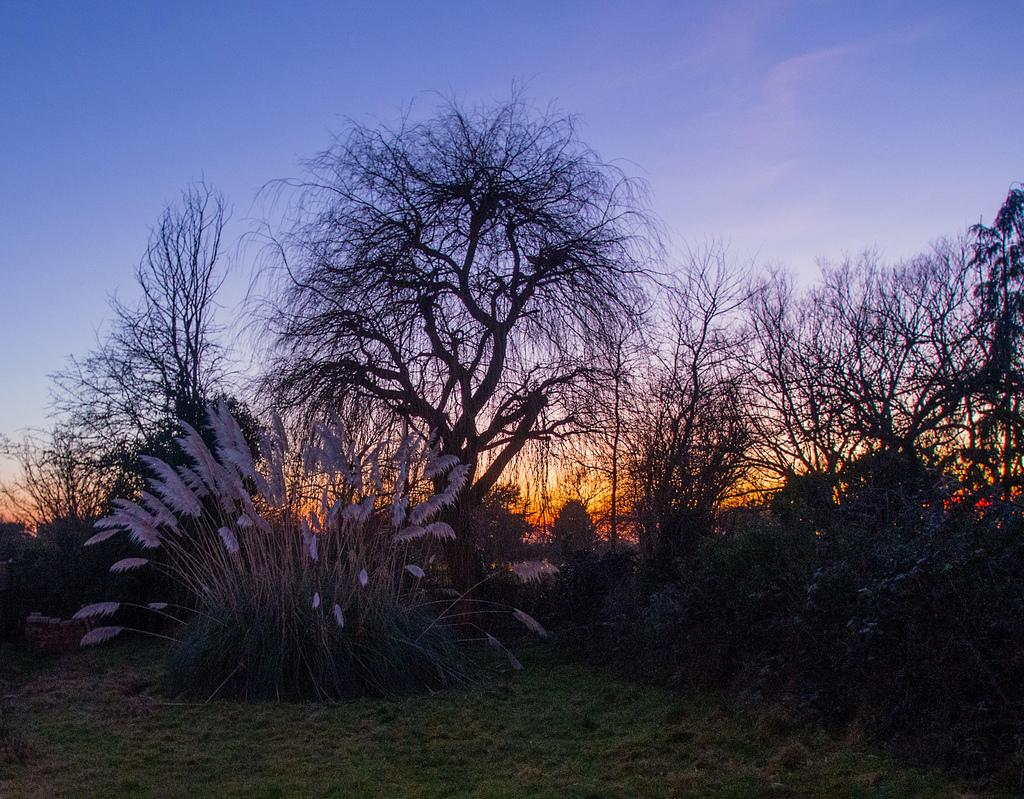What type of vegetation is present on the ground in the image? There are plants on the ground in the image. What is the ground covered with? The ground is covered with grass. What can be seen in the background of the image? There are trees visible in the background of the image. How many goldfish can be seen swimming in the image? There are no goldfish present in the image. What season is depicted in the image? The provided facts do not mention any specific season, so it cannot be determined from the image. 